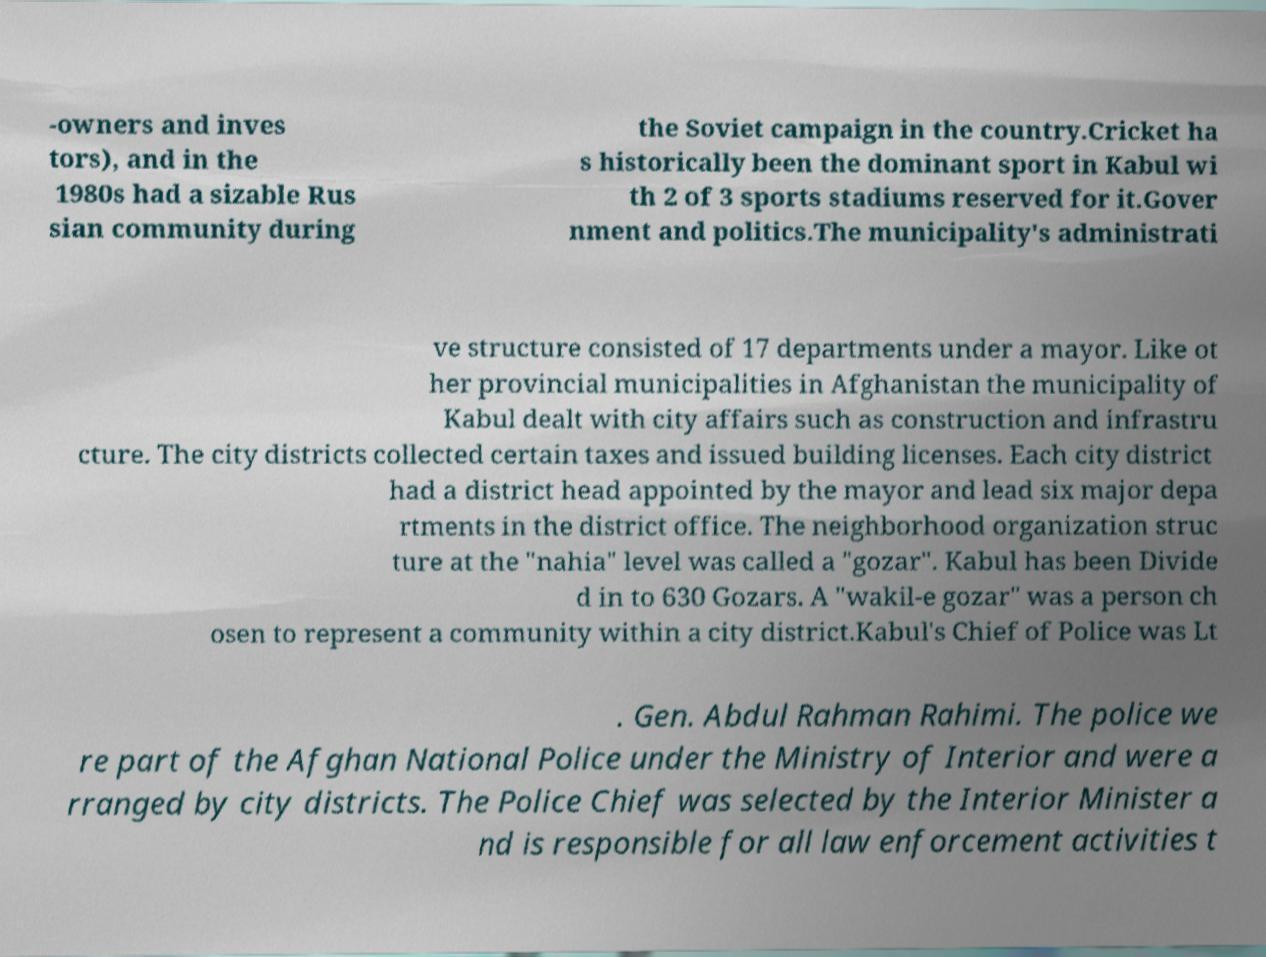I need the written content from this picture converted into text. Can you do that? -owners and inves tors), and in the 1980s had a sizable Rus sian community during the Soviet campaign in the country.Cricket ha s historically been the dominant sport in Kabul wi th 2 of 3 sports stadiums reserved for it.Gover nment and politics.The municipality's administrati ve structure consisted of 17 departments under a mayor. Like ot her provincial municipalities in Afghanistan the municipality of Kabul dealt with city affairs such as construction and infrastru cture. The city districts collected certain taxes and issued building licenses. Each city district had a district head appointed by the mayor and lead six major depa rtments in the district office. The neighborhood organization struc ture at the "nahia" level was called a "gozar". Kabul has been Divide d in to 630 Gozars. A "wakil-e gozar" was a person ch osen to represent a community within a city district.Kabul's Chief of Police was Lt . Gen. Abdul Rahman Rahimi. The police we re part of the Afghan National Police under the Ministry of Interior and were a rranged by city districts. The Police Chief was selected by the Interior Minister a nd is responsible for all law enforcement activities t 